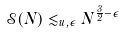<formula> <loc_0><loc_0><loc_500><loc_500>\mathcal { S } ( N ) \lesssim _ { u , \epsilon } N ^ { \frac { 3 } { 2 } - \epsilon }</formula> 